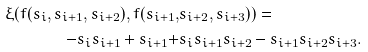<formula> <loc_0><loc_0><loc_500><loc_500>\xi ( f ( s _ { i } , s _ { i + 1 } , s _ { i + 2 } ) , f ( s _ { i + 1 } , & s _ { i + 2 } , s _ { i + 3 } ) ) = \\ - s _ { i } s _ { i + 1 } + s _ { i + 1 } + & s _ { i } s _ { i + 1 } s _ { i + 2 } - s _ { i + 1 } s _ { i + 2 } s _ { i + 3 } .</formula> 